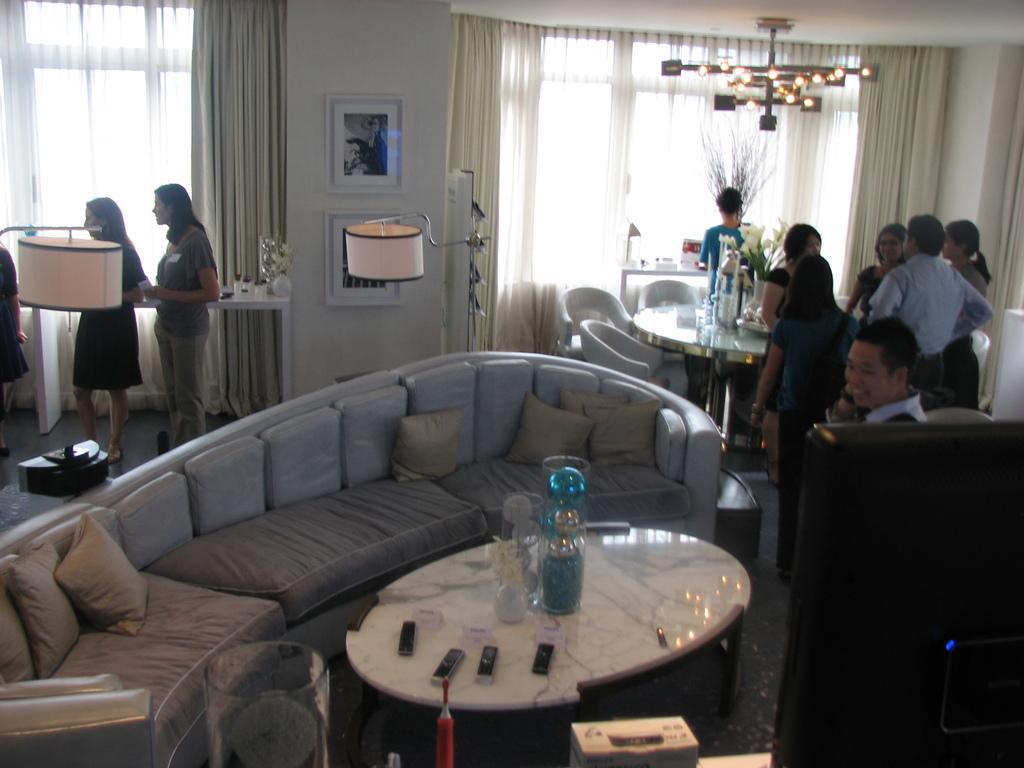Could you give a brief overview of what you see in this image? As we can see in the image, there are few people standing here and there. There is a sofa. On sofa there are pillows. In front of sofa there is a table. On table there are mobile phones and bottles. On the right side there is a dining table and chairs and there is a wall over here. On wall there is a photo frame and bedside wall there is a window and there are cream colored curtains 